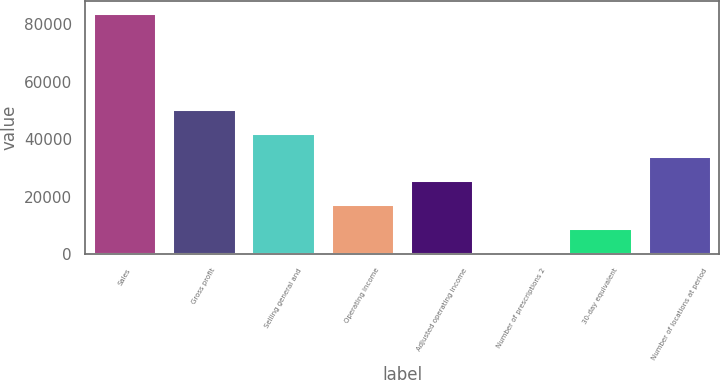Convert chart to OTSL. <chart><loc_0><loc_0><loc_500><loc_500><bar_chart><fcel>Sales<fcel>Gross profit<fcel>Selling general and<fcel>Operating income<fcel>Adjusted operating income<fcel>Number of prescriptions 2<fcel>30-day equivalent<fcel>Number of locations at period<nl><fcel>83802<fcel>50577.2<fcel>42271.1<fcel>17352.5<fcel>25658.7<fcel>740.1<fcel>9046.29<fcel>33964.9<nl></chart> 